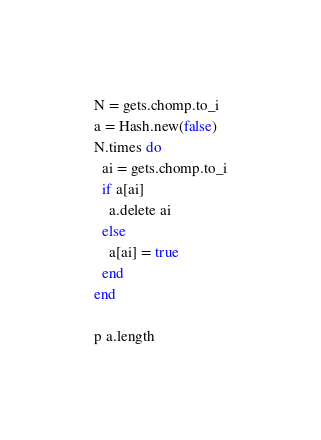Convert code to text. <code><loc_0><loc_0><loc_500><loc_500><_Ruby_>N = gets.chomp.to_i
a = Hash.new(false)
N.times do
  ai = gets.chomp.to_i
  if a[ai]
    a.delete ai
  else
    a[ai] = true
  end
end

p a.length</code> 